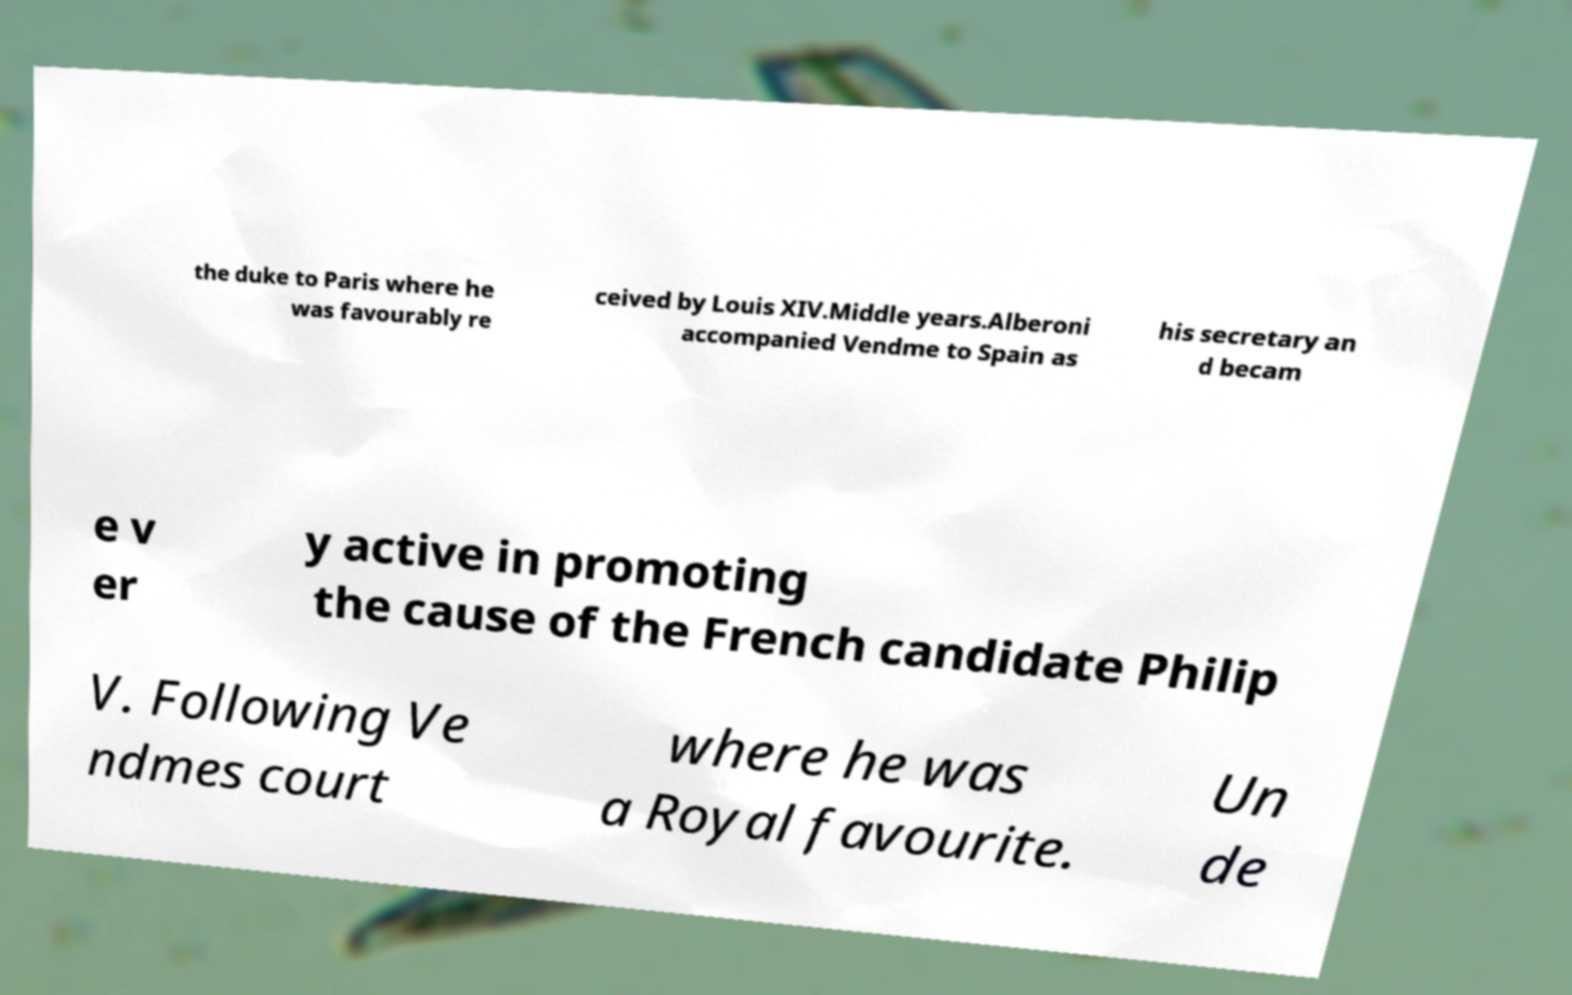Can you read and provide the text displayed in the image?This photo seems to have some interesting text. Can you extract and type it out for me? the duke to Paris where he was favourably re ceived by Louis XIV.Middle years.Alberoni accompanied Vendme to Spain as his secretary an d becam e v er y active in promoting the cause of the French candidate Philip V. Following Ve ndmes court where he was a Royal favourite. Un de 